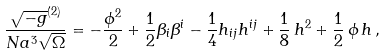<formula> <loc_0><loc_0><loc_500><loc_500>\frac { \sqrt { - g } ^ { ( 2 ) } } { N a ^ { 3 } \sqrt { \Omega } } = - \frac { \phi ^ { 2 } } { 2 } + \frac { 1 } { 2 } \beta _ { i } \beta ^ { i } - \frac { 1 } { 4 } h _ { i j } h ^ { i j } + \frac { 1 } { 8 } \, h ^ { 2 } + \frac { 1 } { 2 } \, \phi \, h \, ,</formula> 